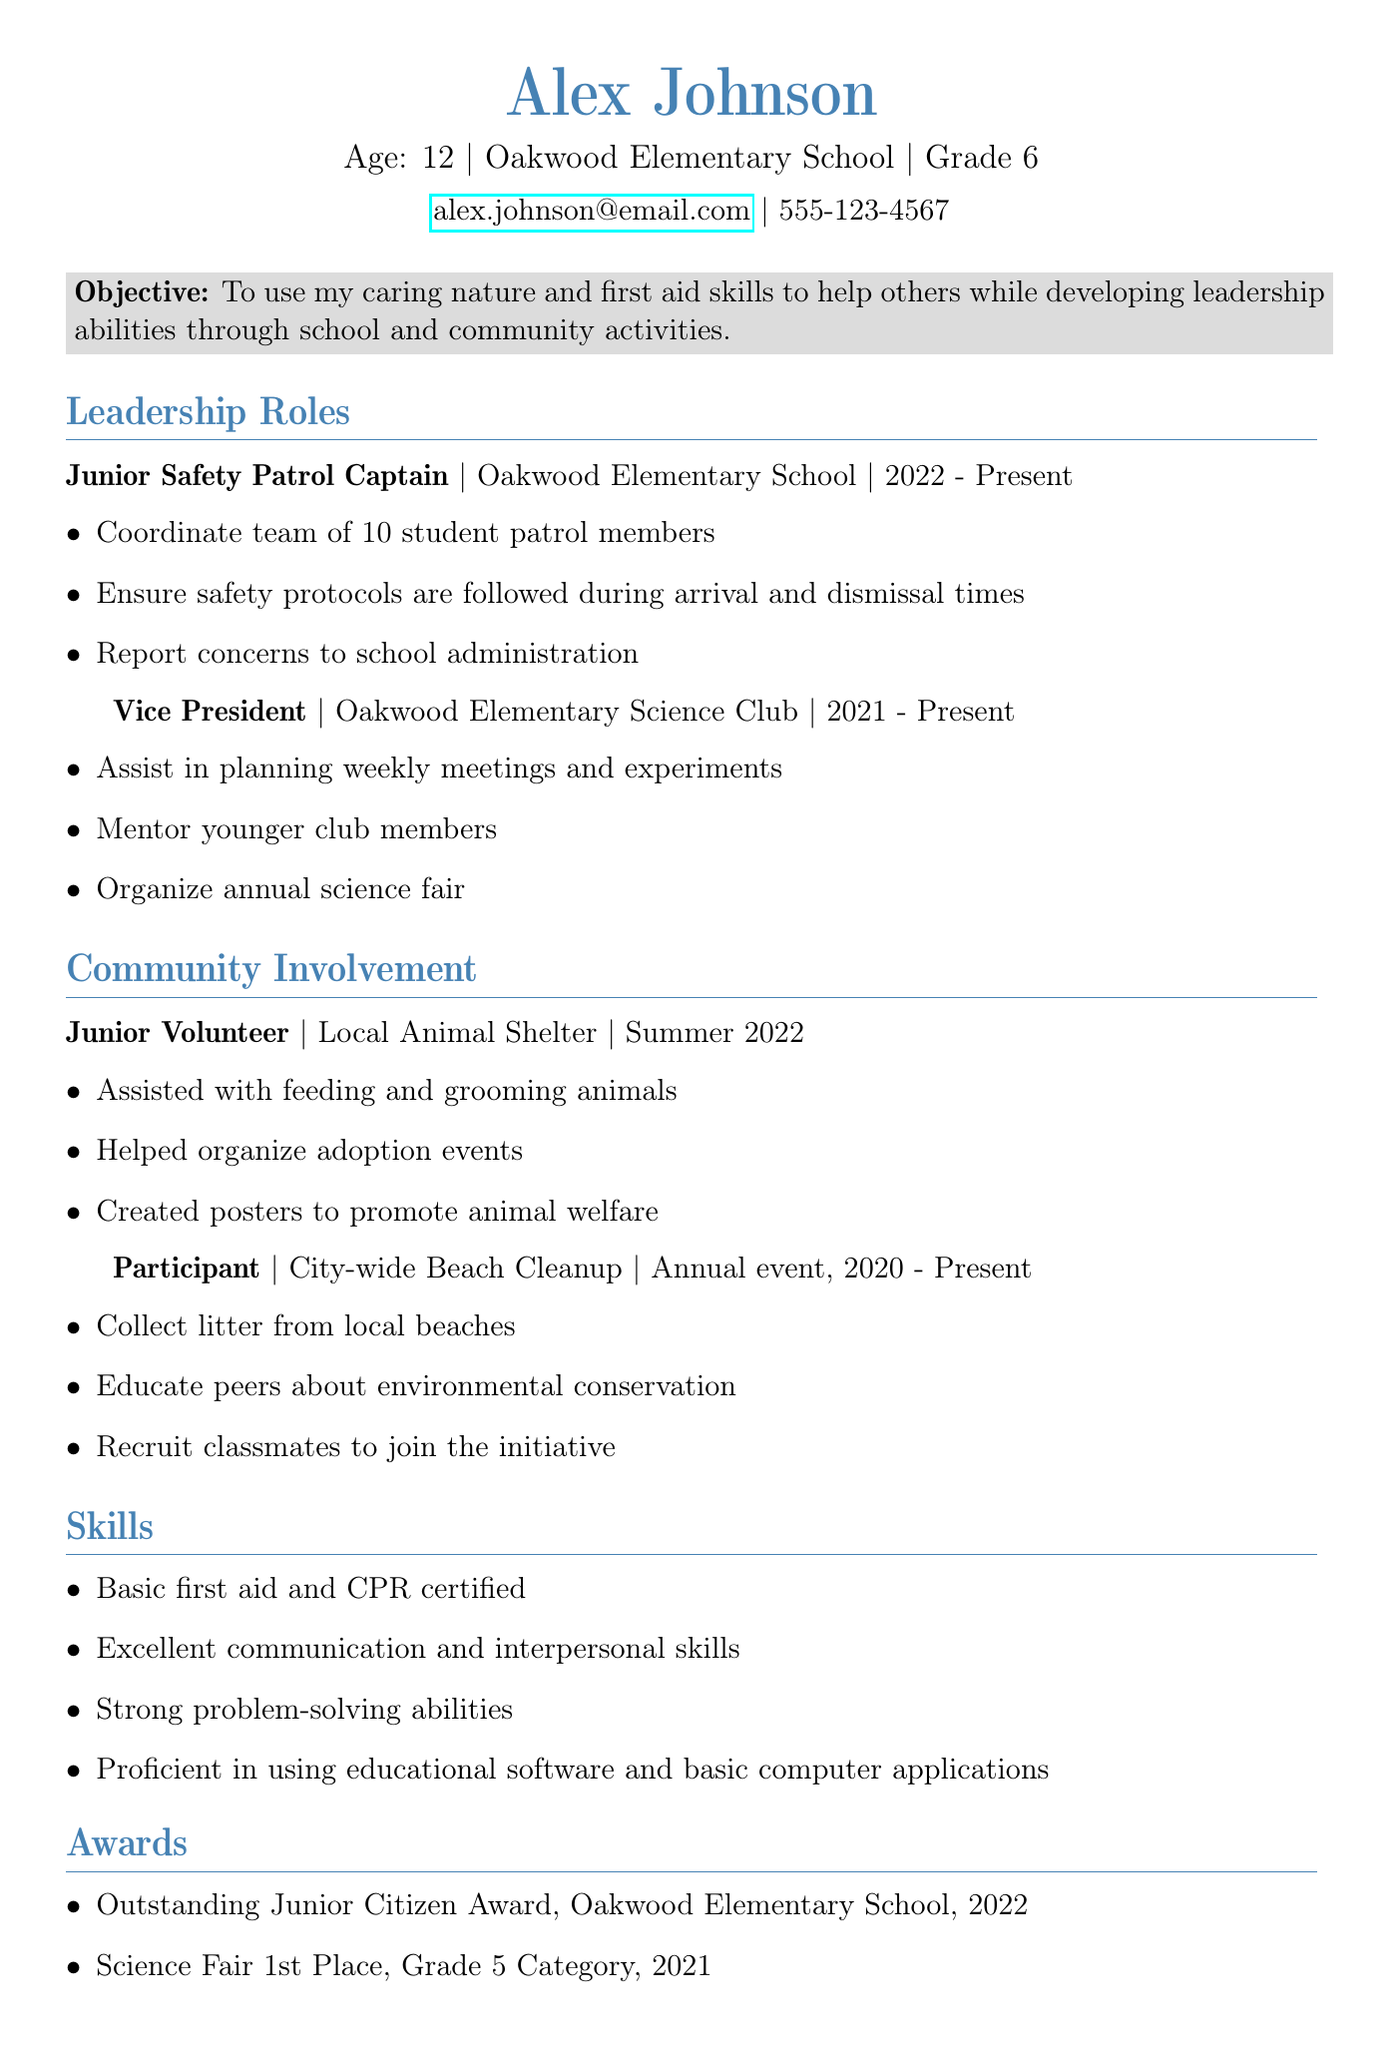What is Alex's age? Alex's age is explicitly mentioned in the personal info section of the document.
Answer: 12 What grade is Alex in? The document specifies the grade level in the personal info section.
Answer: 6 What is the title of Alex's leadership role in the Safety Patrol? The title is clearly listed under the leadership roles section.
Answer: Junior Safety Patrol Captain Which organization is the Science Club associated with? This information is provided under the leadership roles section.
Answer: Oakwood Elementary Science Club What activity did Alex participate in related to environmental conservation? The activity is described in the community involvement section.
Answer: City-wide Beach Cleanup How many student patrol members does Alex coordinate? The number of members is stated in the responsibilities under the Junior Safety Patrol Captain role.
Answer: 10 What skill is Alex certified in? The skills section lists Alex's certifications.
Answer: Basic first aid and CPR In which year did Alex win the Outstanding Junior Citizen Award? The award date is mentioned in the awards section of the document.
Answer: 2022 What role does Alex have in the Science Club? The specific leadership role is highlighted in the leadership roles section.
Answer: Vice President 